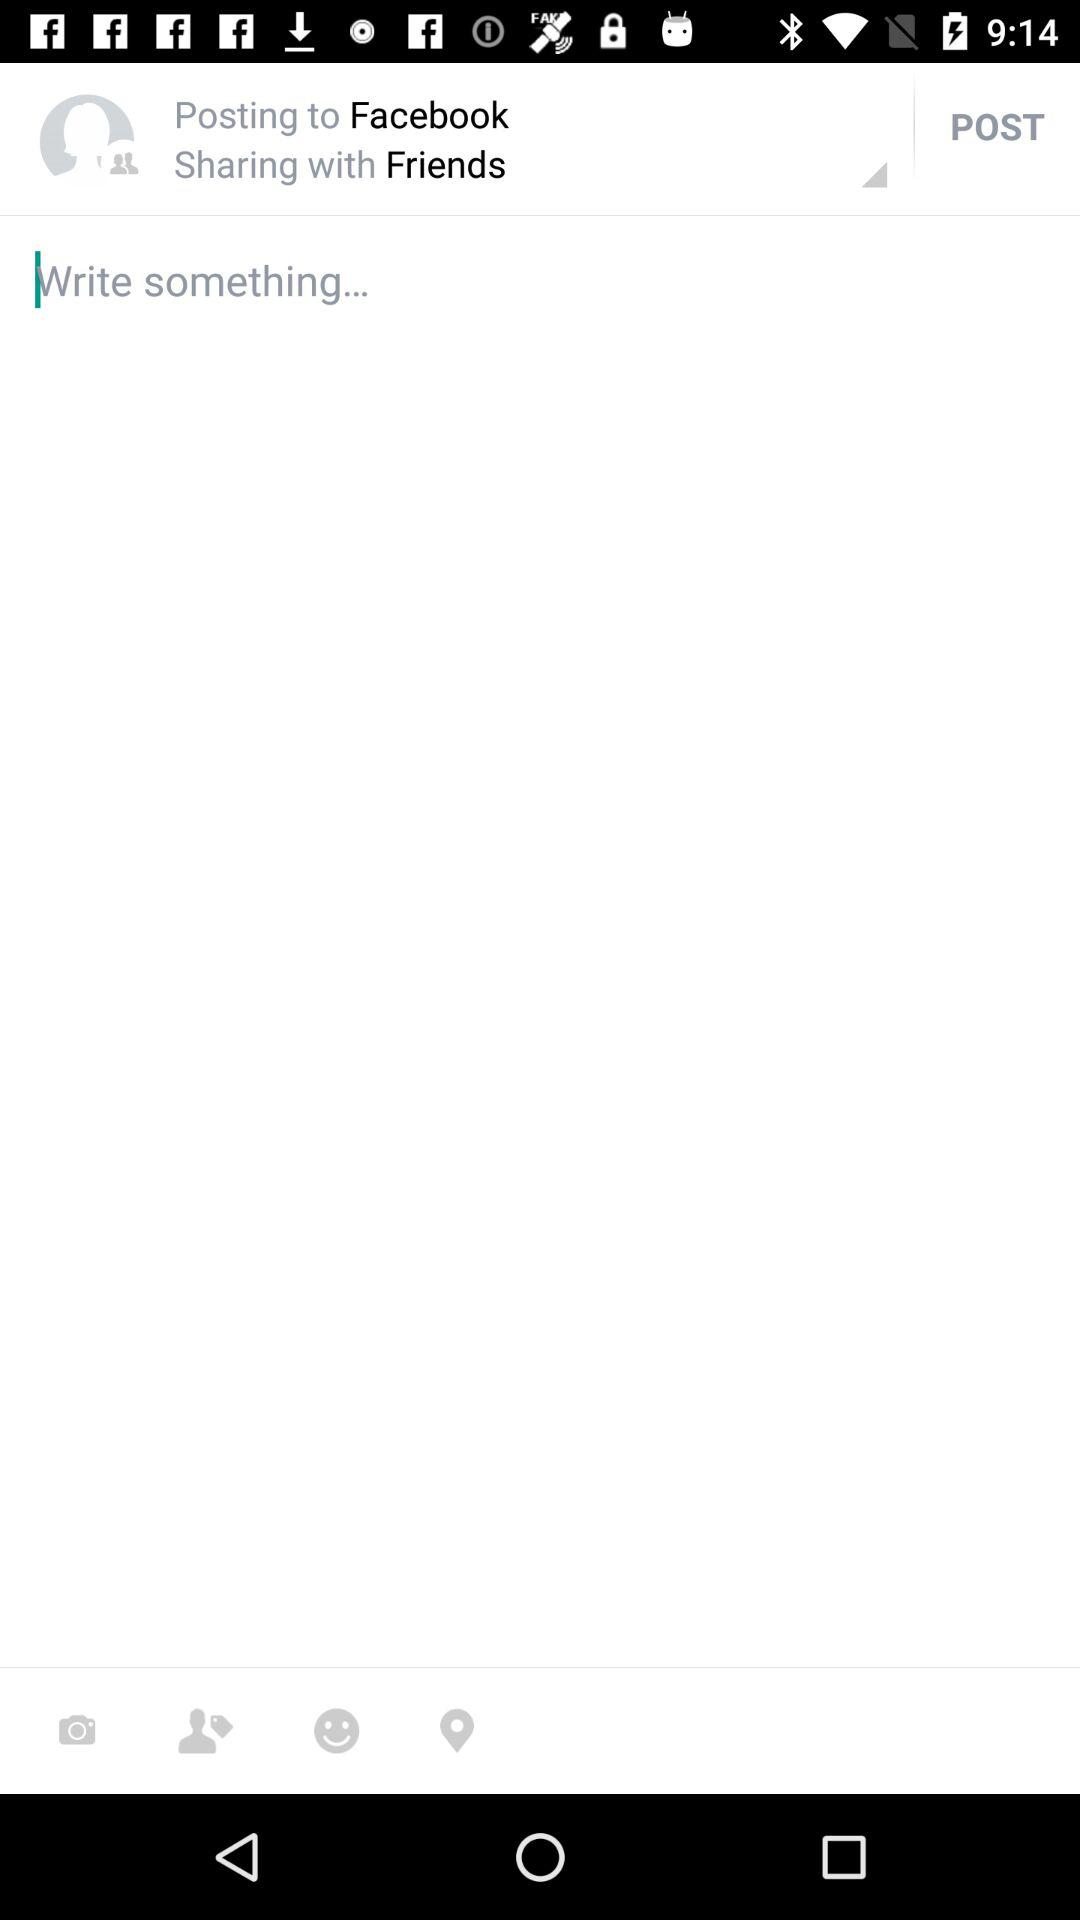With whom will the post be shared? The post will be shared with friends. 